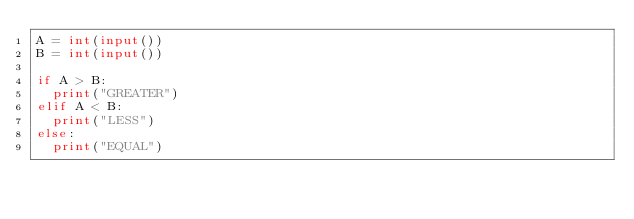Convert code to text. <code><loc_0><loc_0><loc_500><loc_500><_Python_>A = int(input())
B = int(input())

if A > B:
  print("GREATER")
elif A < B:
  print("LESS")
else:
  print("EQUAL")
</code> 